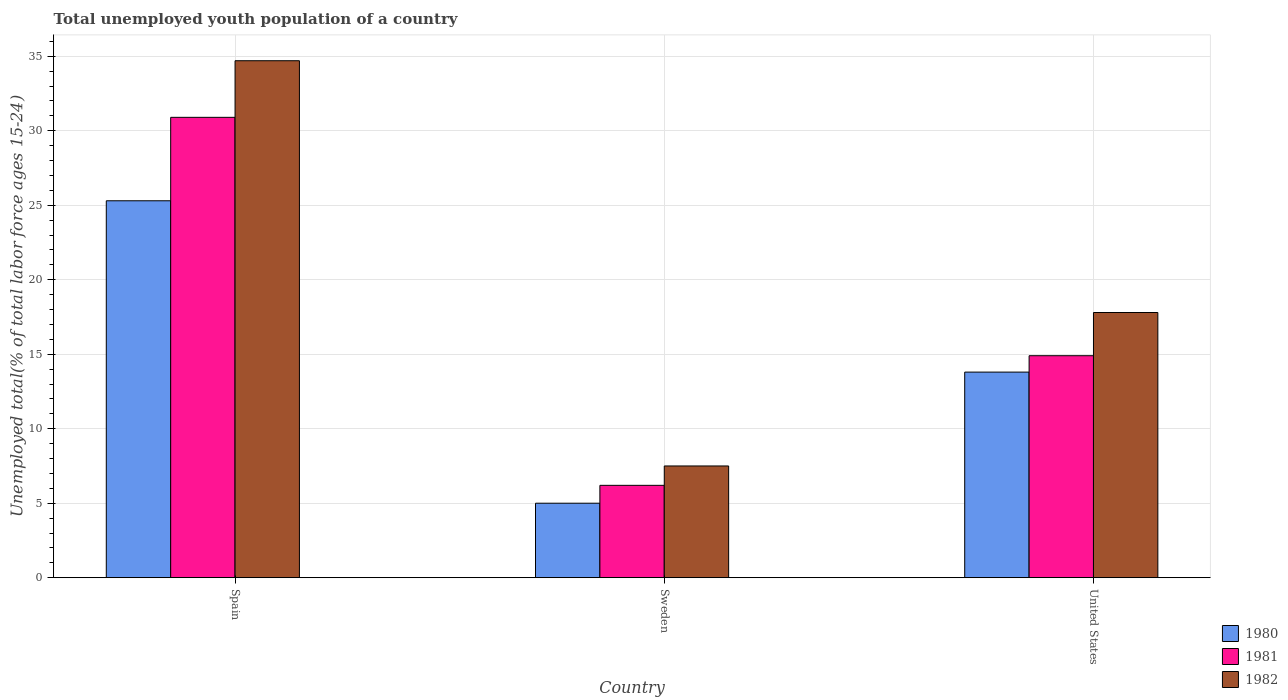Are the number of bars per tick equal to the number of legend labels?
Your answer should be compact. Yes. Are the number of bars on each tick of the X-axis equal?
Your response must be concise. Yes. How many bars are there on the 2nd tick from the right?
Provide a short and direct response. 3. What is the label of the 3rd group of bars from the left?
Keep it short and to the point. United States. In how many cases, is the number of bars for a given country not equal to the number of legend labels?
Provide a short and direct response. 0. What is the percentage of total unemployed youth population of a country in 1981 in Spain?
Offer a very short reply. 30.9. Across all countries, what is the maximum percentage of total unemployed youth population of a country in 1980?
Your response must be concise. 25.3. Across all countries, what is the minimum percentage of total unemployed youth population of a country in 1982?
Your answer should be compact. 7.5. In which country was the percentage of total unemployed youth population of a country in 1980 maximum?
Ensure brevity in your answer.  Spain. What is the total percentage of total unemployed youth population of a country in 1981 in the graph?
Keep it short and to the point. 52. What is the difference between the percentage of total unemployed youth population of a country in 1982 in Sweden and that in United States?
Your answer should be very brief. -10.3. What is the difference between the percentage of total unemployed youth population of a country in 1982 in Spain and the percentage of total unemployed youth population of a country in 1981 in Sweden?
Keep it short and to the point. 28.5. What is the average percentage of total unemployed youth population of a country in 1982 per country?
Offer a very short reply. 20. What is the difference between the percentage of total unemployed youth population of a country of/in 1982 and percentage of total unemployed youth population of a country of/in 1981 in United States?
Provide a succinct answer. 2.9. In how many countries, is the percentage of total unemployed youth population of a country in 1982 greater than 2 %?
Your answer should be very brief. 3. What is the ratio of the percentage of total unemployed youth population of a country in 1980 in Spain to that in Sweden?
Make the answer very short. 5.06. Is the difference between the percentage of total unemployed youth population of a country in 1982 in Sweden and United States greater than the difference between the percentage of total unemployed youth population of a country in 1981 in Sweden and United States?
Ensure brevity in your answer.  No. What is the difference between the highest and the second highest percentage of total unemployed youth population of a country in 1980?
Provide a short and direct response. 20.3. What is the difference between the highest and the lowest percentage of total unemployed youth population of a country in 1982?
Provide a short and direct response. 27.2. In how many countries, is the percentage of total unemployed youth population of a country in 1980 greater than the average percentage of total unemployed youth population of a country in 1980 taken over all countries?
Make the answer very short. 1. What does the 1st bar from the right in United States represents?
Provide a short and direct response. 1982. Is it the case that in every country, the sum of the percentage of total unemployed youth population of a country in 1980 and percentage of total unemployed youth population of a country in 1982 is greater than the percentage of total unemployed youth population of a country in 1981?
Provide a short and direct response. Yes. What is the difference between two consecutive major ticks on the Y-axis?
Give a very brief answer. 5. Does the graph contain grids?
Give a very brief answer. Yes. Where does the legend appear in the graph?
Offer a terse response. Bottom right. How many legend labels are there?
Keep it short and to the point. 3. How are the legend labels stacked?
Ensure brevity in your answer.  Vertical. What is the title of the graph?
Provide a succinct answer. Total unemployed youth population of a country. Does "2003" appear as one of the legend labels in the graph?
Your answer should be compact. No. What is the label or title of the Y-axis?
Give a very brief answer. Unemployed total(% of total labor force ages 15-24). What is the Unemployed total(% of total labor force ages 15-24) in 1980 in Spain?
Keep it short and to the point. 25.3. What is the Unemployed total(% of total labor force ages 15-24) in 1981 in Spain?
Your answer should be compact. 30.9. What is the Unemployed total(% of total labor force ages 15-24) in 1982 in Spain?
Your response must be concise. 34.7. What is the Unemployed total(% of total labor force ages 15-24) of 1981 in Sweden?
Offer a terse response. 6.2. What is the Unemployed total(% of total labor force ages 15-24) of 1982 in Sweden?
Make the answer very short. 7.5. What is the Unemployed total(% of total labor force ages 15-24) in 1980 in United States?
Keep it short and to the point. 13.8. What is the Unemployed total(% of total labor force ages 15-24) in 1981 in United States?
Your response must be concise. 14.9. What is the Unemployed total(% of total labor force ages 15-24) of 1982 in United States?
Keep it short and to the point. 17.8. Across all countries, what is the maximum Unemployed total(% of total labor force ages 15-24) of 1980?
Offer a terse response. 25.3. Across all countries, what is the maximum Unemployed total(% of total labor force ages 15-24) in 1981?
Make the answer very short. 30.9. Across all countries, what is the maximum Unemployed total(% of total labor force ages 15-24) in 1982?
Offer a very short reply. 34.7. Across all countries, what is the minimum Unemployed total(% of total labor force ages 15-24) of 1980?
Your answer should be very brief. 5. Across all countries, what is the minimum Unemployed total(% of total labor force ages 15-24) of 1981?
Keep it short and to the point. 6.2. What is the total Unemployed total(% of total labor force ages 15-24) of 1980 in the graph?
Your answer should be compact. 44.1. What is the difference between the Unemployed total(% of total labor force ages 15-24) of 1980 in Spain and that in Sweden?
Your response must be concise. 20.3. What is the difference between the Unemployed total(% of total labor force ages 15-24) in 1981 in Spain and that in Sweden?
Your response must be concise. 24.7. What is the difference between the Unemployed total(% of total labor force ages 15-24) in 1982 in Spain and that in Sweden?
Give a very brief answer. 27.2. What is the difference between the Unemployed total(% of total labor force ages 15-24) of 1980 in Spain and that in United States?
Provide a succinct answer. 11.5. What is the difference between the Unemployed total(% of total labor force ages 15-24) in 1981 in Spain and that in United States?
Offer a terse response. 16. What is the difference between the Unemployed total(% of total labor force ages 15-24) in 1982 in Spain and that in United States?
Make the answer very short. 16.9. What is the difference between the Unemployed total(% of total labor force ages 15-24) in 1980 in Sweden and that in United States?
Make the answer very short. -8.8. What is the difference between the Unemployed total(% of total labor force ages 15-24) of 1982 in Sweden and that in United States?
Offer a terse response. -10.3. What is the difference between the Unemployed total(% of total labor force ages 15-24) in 1980 in Spain and the Unemployed total(% of total labor force ages 15-24) in 1981 in Sweden?
Give a very brief answer. 19.1. What is the difference between the Unemployed total(% of total labor force ages 15-24) in 1981 in Spain and the Unemployed total(% of total labor force ages 15-24) in 1982 in Sweden?
Offer a terse response. 23.4. What is the difference between the Unemployed total(% of total labor force ages 15-24) in 1980 in Spain and the Unemployed total(% of total labor force ages 15-24) in 1981 in United States?
Offer a terse response. 10.4. What is the difference between the Unemployed total(% of total labor force ages 15-24) in 1980 in Sweden and the Unemployed total(% of total labor force ages 15-24) in 1981 in United States?
Offer a very short reply. -9.9. What is the difference between the Unemployed total(% of total labor force ages 15-24) of 1980 in Sweden and the Unemployed total(% of total labor force ages 15-24) of 1982 in United States?
Ensure brevity in your answer.  -12.8. What is the difference between the Unemployed total(% of total labor force ages 15-24) in 1981 in Sweden and the Unemployed total(% of total labor force ages 15-24) in 1982 in United States?
Ensure brevity in your answer.  -11.6. What is the average Unemployed total(% of total labor force ages 15-24) in 1981 per country?
Provide a succinct answer. 17.33. What is the difference between the Unemployed total(% of total labor force ages 15-24) in 1980 and Unemployed total(% of total labor force ages 15-24) in 1981 in Spain?
Give a very brief answer. -5.6. What is the difference between the Unemployed total(% of total labor force ages 15-24) in 1980 and Unemployed total(% of total labor force ages 15-24) in 1982 in Spain?
Provide a short and direct response. -9.4. What is the difference between the Unemployed total(% of total labor force ages 15-24) in 1981 and Unemployed total(% of total labor force ages 15-24) in 1982 in Spain?
Your answer should be very brief. -3.8. What is the difference between the Unemployed total(% of total labor force ages 15-24) of 1980 and Unemployed total(% of total labor force ages 15-24) of 1981 in Sweden?
Ensure brevity in your answer.  -1.2. What is the difference between the Unemployed total(% of total labor force ages 15-24) of 1980 and Unemployed total(% of total labor force ages 15-24) of 1982 in Sweden?
Your answer should be compact. -2.5. What is the ratio of the Unemployed total(% of total labor force ages 15-24) in 1980 in Spain to that in Sweden?
Keep it short and to the point. 5.06. What is the ratio of the Unemployed total(% of total labor force ages 15-24) in 1981 in Spain to that in Sweden?
Offer a very short reply. 4.98. What is the ratio of the Unemployed total(% of total labor force ages 15-24) in 1982 in Spain to that in Sweden?
Keep it short and to the point. 4.63. What is the ratio of the Unemployed total(% of total labor force ages 15-24) of 1980 in Spain to that in United States?
Your answer should be compact. 1.83. What is the ratio of the Unemployed total(% of total labor force ages 15-24) of 1981 in Spain to that in United States?
Provide a short and direct response. 2.07. What is the ratio of the Unemployed total(% of total labor force ages 15-24) in 1982 in Spain to that in United States?
Ensure brevity in your answer.  1.95. What is the ratio of the Unemployed total(% of total labor force ages 15-24) of 1980 in Sweden to that in United States?
Offer a terse response. 0.36. What is the ratio of the Unemployed total(% of total labor force ages 15-24) in 1981 in Sweden to that in United States?
Give a very brief answer. 0.42. What is the ratio of the Unemployed total(% of total labor force ages 15-24) in 1982 in Sweden to that in United States?
Provide a succinct answer. 0.42. What is the difference between the highest and the second highest Unemployed total(% of total labor force ages 15-24) in 1981?
Provide a succinct answer. 16. What is the difference between the highest and the lowest Unemployed total(% of total labor force ages 15-24) in 1980?
Provide a short and direct response. 20.3. What is the difference between the highest and the lowest Unemployed total(% of total labor force ages 15-24) in 1981?
Keep it short and to the point. 24.7. What is the difference between the highest and the lowest Unemployed total(% of total labor force ages 15-24) of 1982?
Make the answer very short. 27.2. 